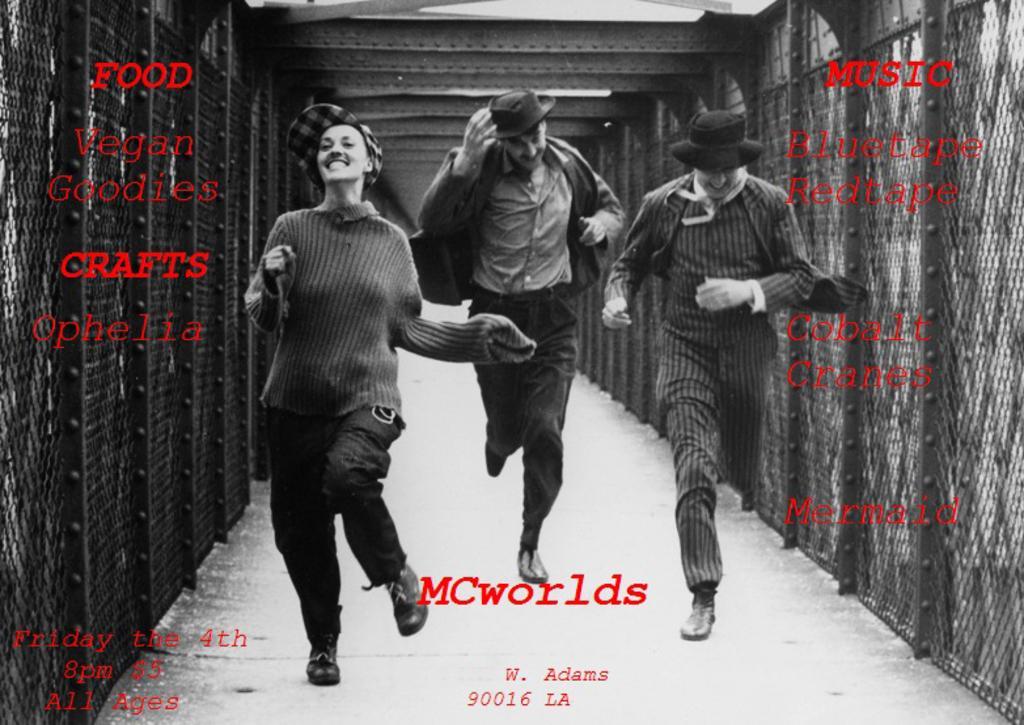Could you give a brief overview of what you see in this image? In this picture there are people running on the bridge and we can see meshes and text. 